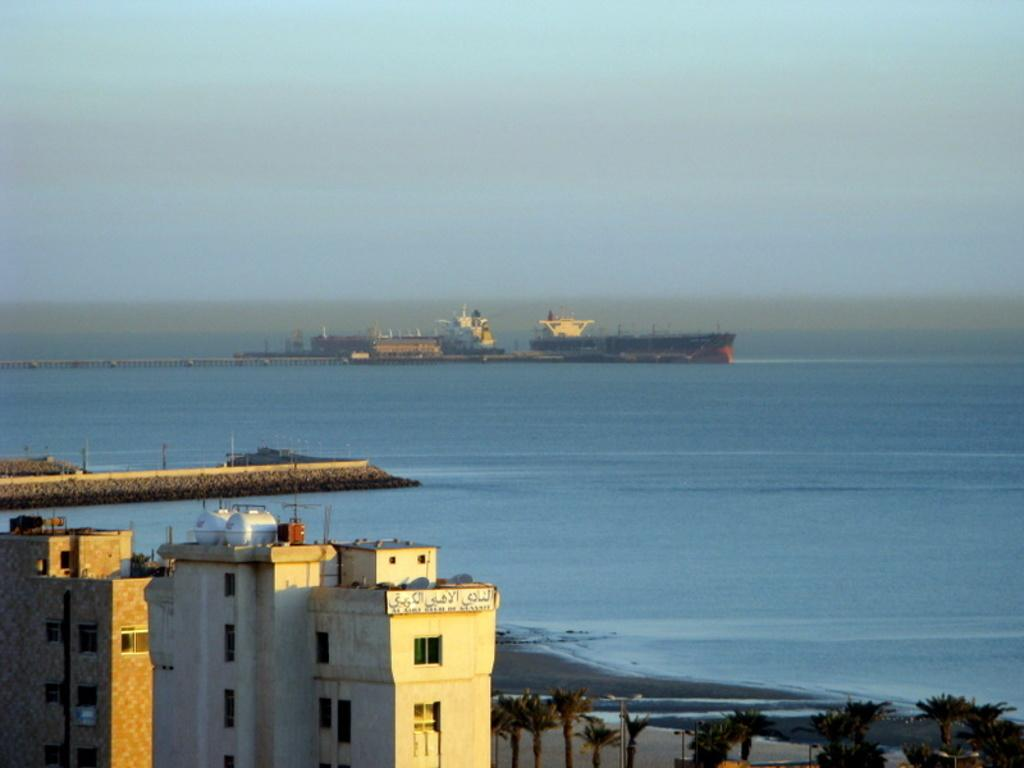What can be seen in the front of the image? There are buildings and trees in the front of the image. What is located in the center of the image? There is water in the center of the image. What can be seen in the background of the image? There are buildings in the background of the image. How many chains are hanging from the trees in the image? There are no chains visible in the image; only buildings, trees, and water are present. Is there a kite flying in the sky in the image? There is no kite present in the image; the sky is not mentioned in the provided facts. 